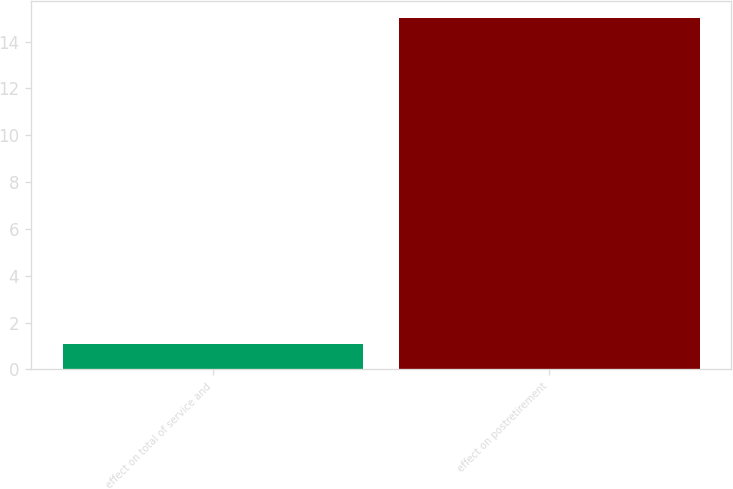Convert chart. <chart><loc_0><loc_0><loc_500><loc_500><bar_chart><fcel>effect on total of service and<fcel>effect on postretirement<nl><fcel>1.1<fcel>15<nl></chart> 